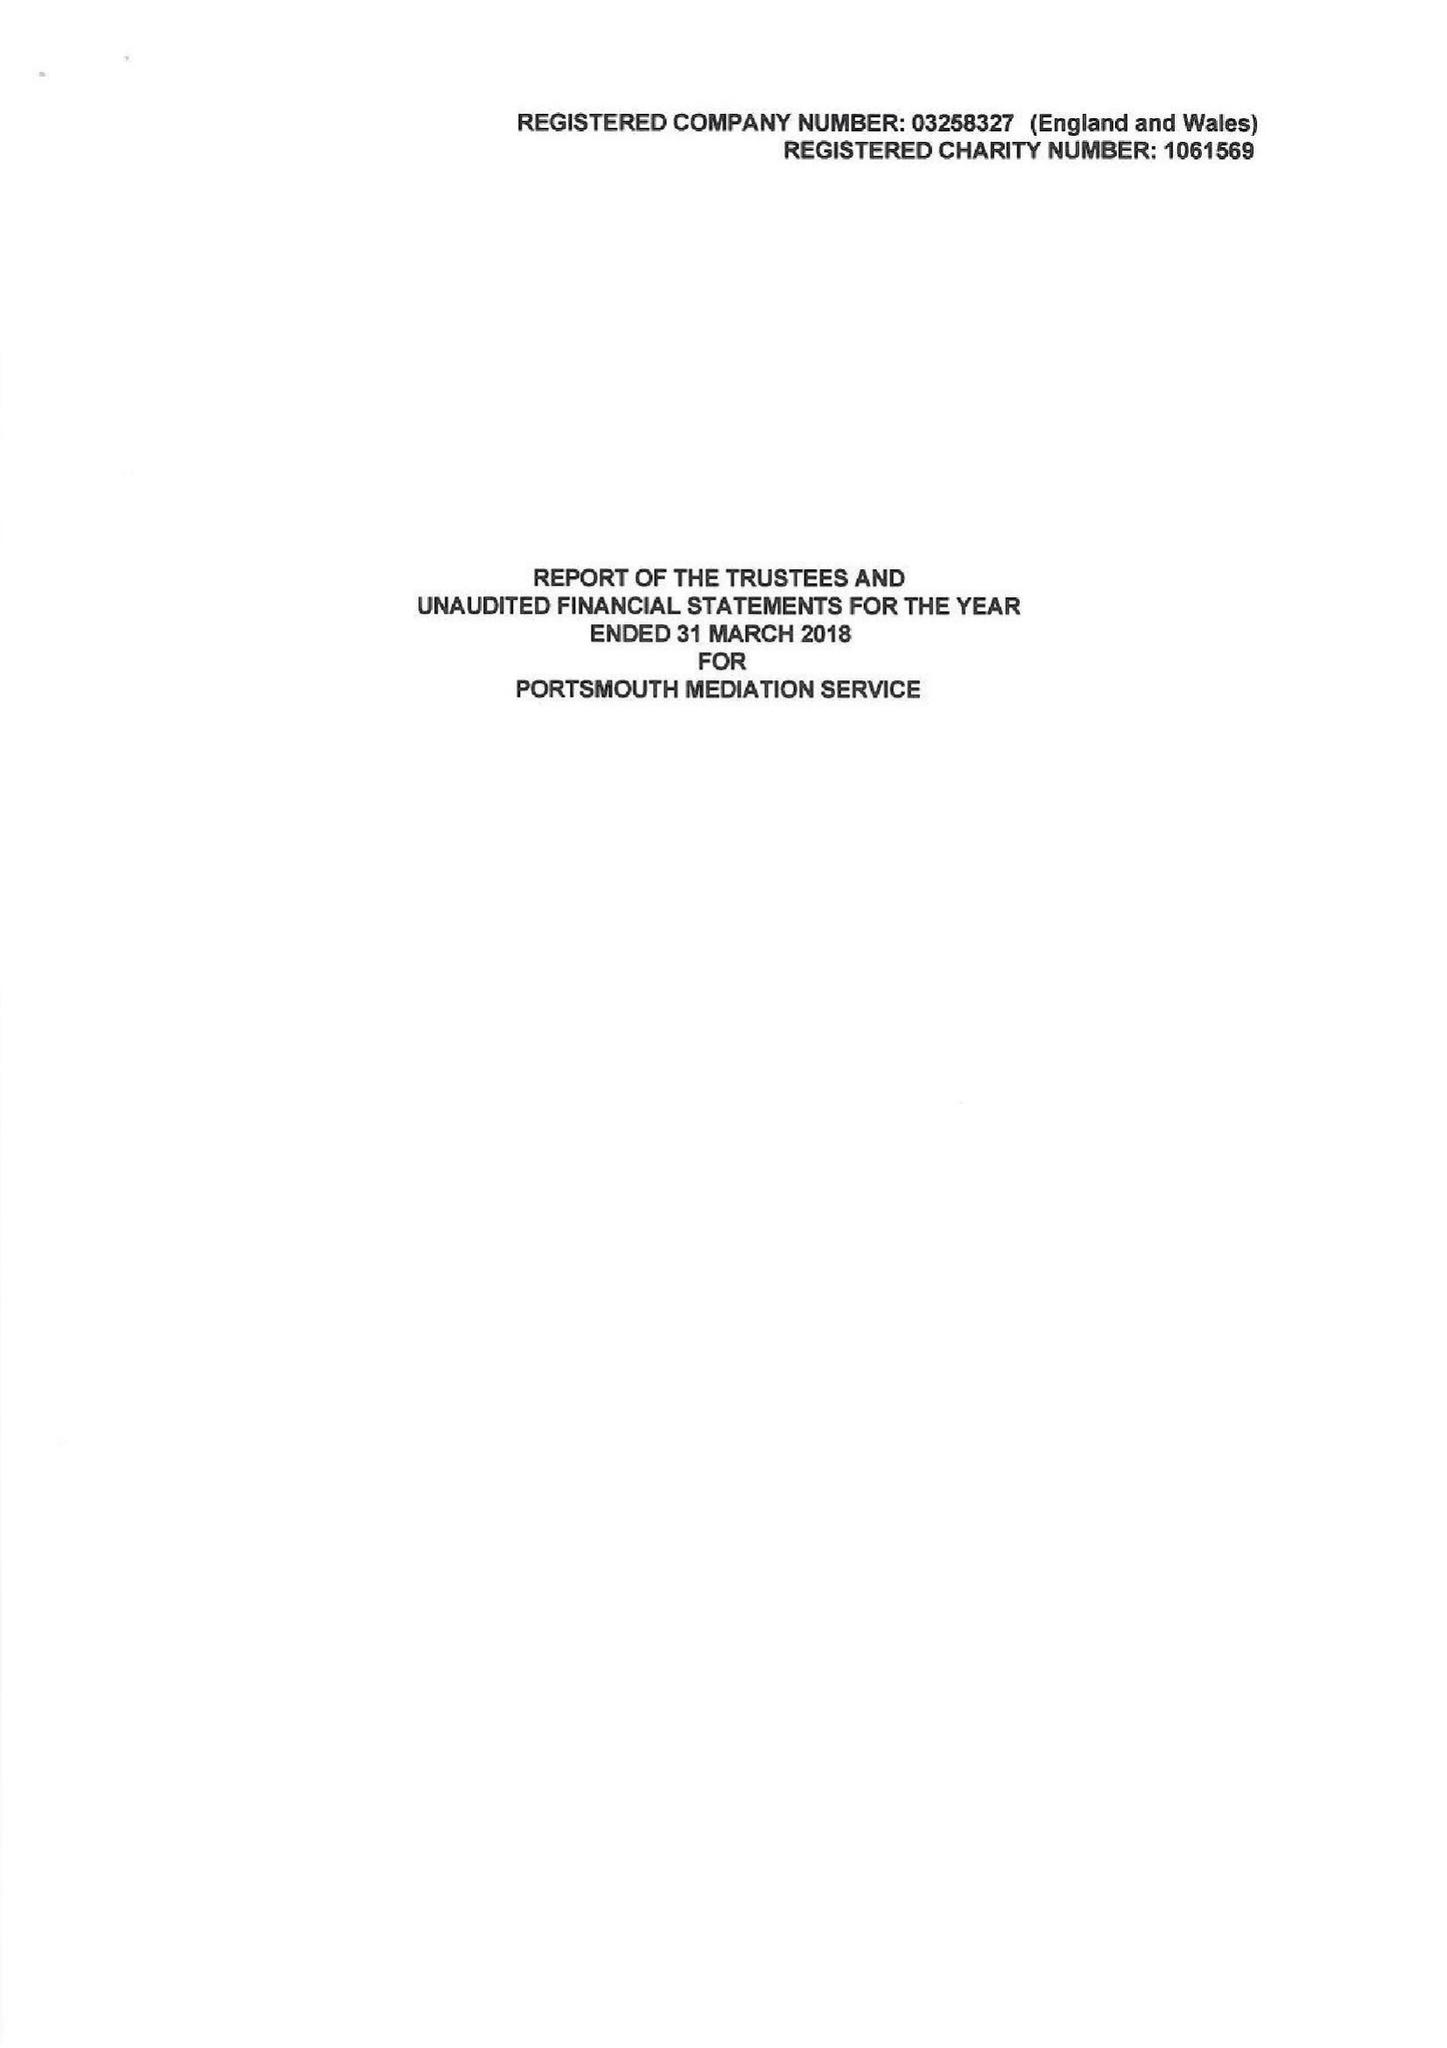What is the value for the income_annually_in_british_pounds?
Answer the question using a single word or phrase. 151204.00 